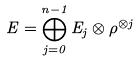Convert formula to latex. <formula><loc_0><loc_0><loc_500><loc_500>E = \bigoplus _ { j = 0 } ^ { n - 1 } E _ { j } \otimes \rho ^ { \otimes j }</formula> 